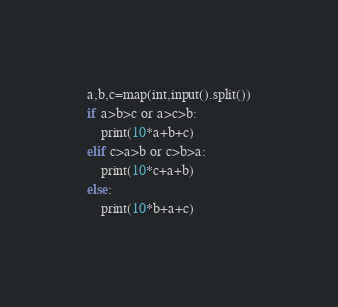Convert code to text. <code><loc_0><loc_0><loc_500><loc_500><_Python_>a,b,c=map(int,input().split())
if a>b>c or a>c>b:
    print(10*a+b+c)
elif c>a>b or c>b>a:
    print(10*c+a+b)
else:
    print(10*b+a+c)</code> 